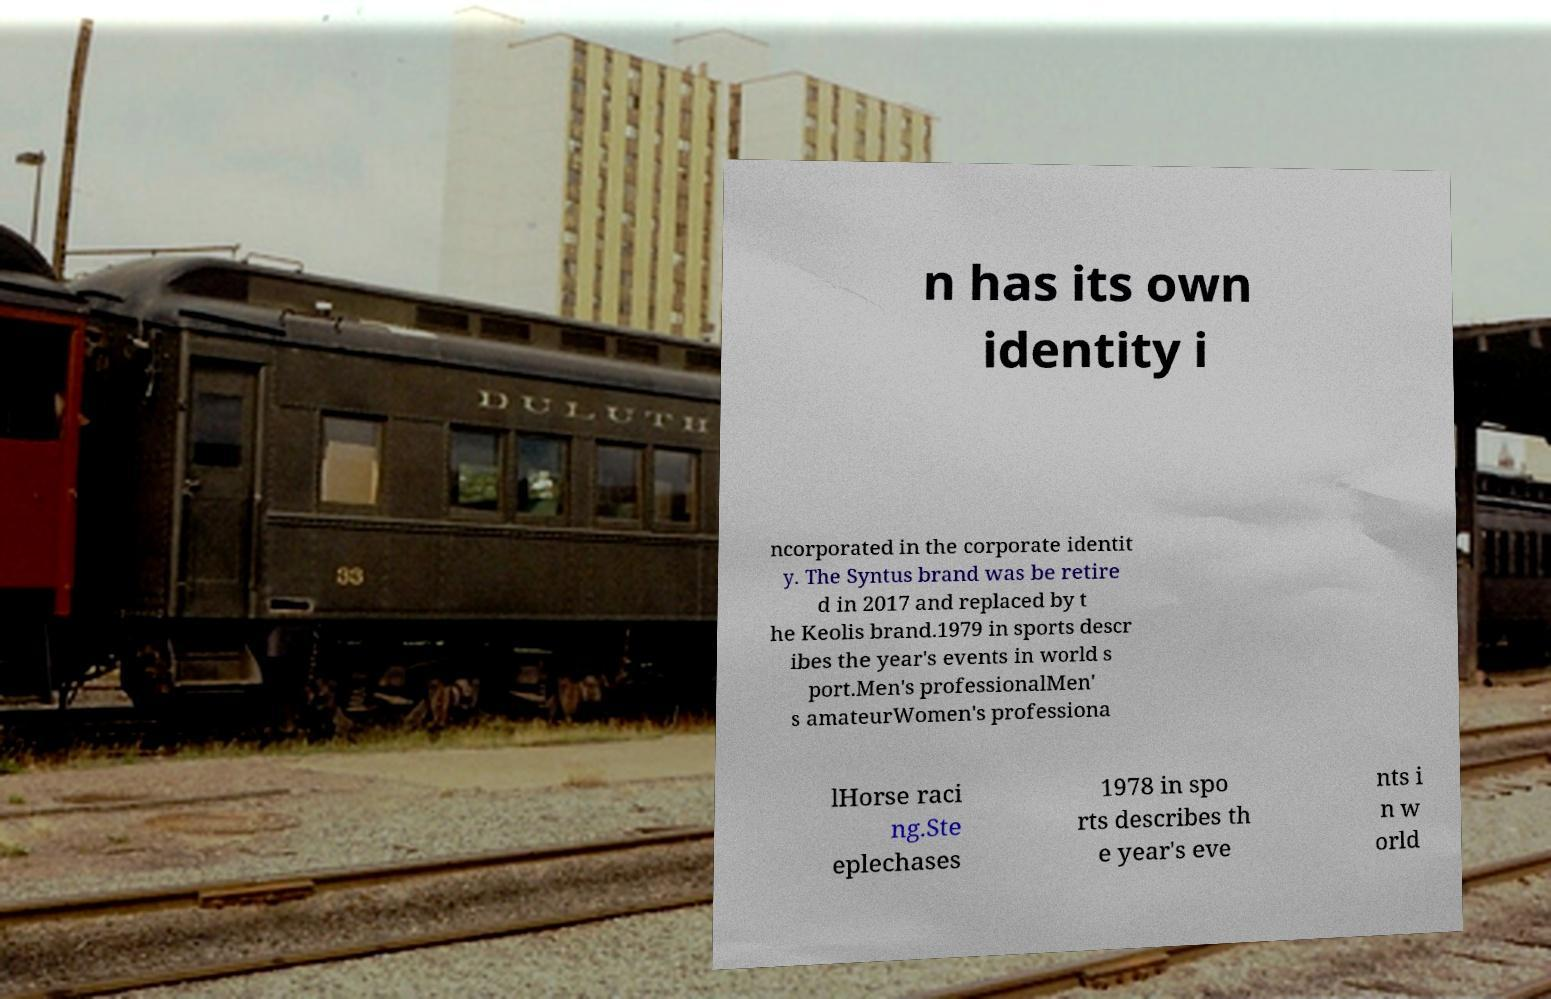For documentation purposes, I need the text within this image transcribed. Could you provide that? n has its own identity i ncorporated in the corporate identit y. The Syntus brand was be retire d in 2017 and replaced by t he Keolis brand.1979 in sports descr ibes the year's events in world s port.Men's professionalMen' s amateurWomen's professiona lHorse raci ng.Ste eplechases 1978 in spo rts describes th e year's eve nts i n w orld 